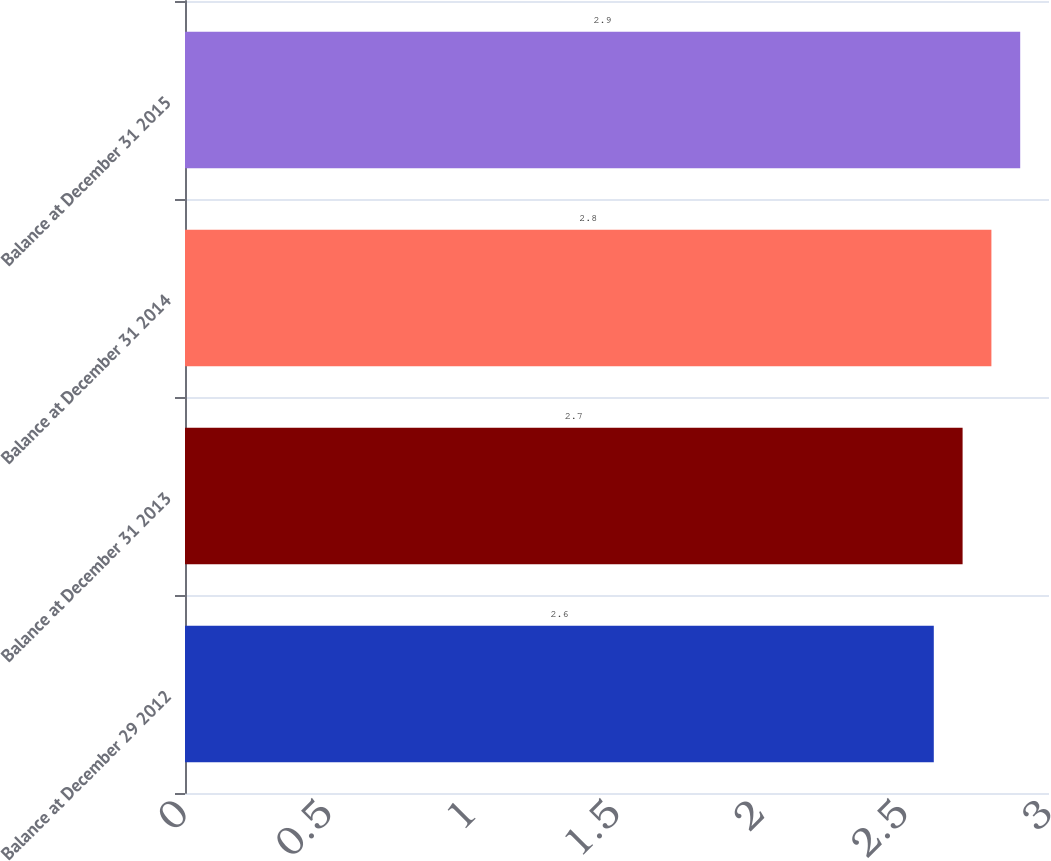<chart> <loc_0><loc_0><loc_500><loc_500><bar_chart><fcel>Balance at December 29 2012<fcel>Balance at December 31 2013<fcel>Balance at December 31 2014<fcel>Balance at December 31 2015<nl><fcel>2.6<fcel>2.7<fcel>2.8<fcel>2.9<nl></chart> 